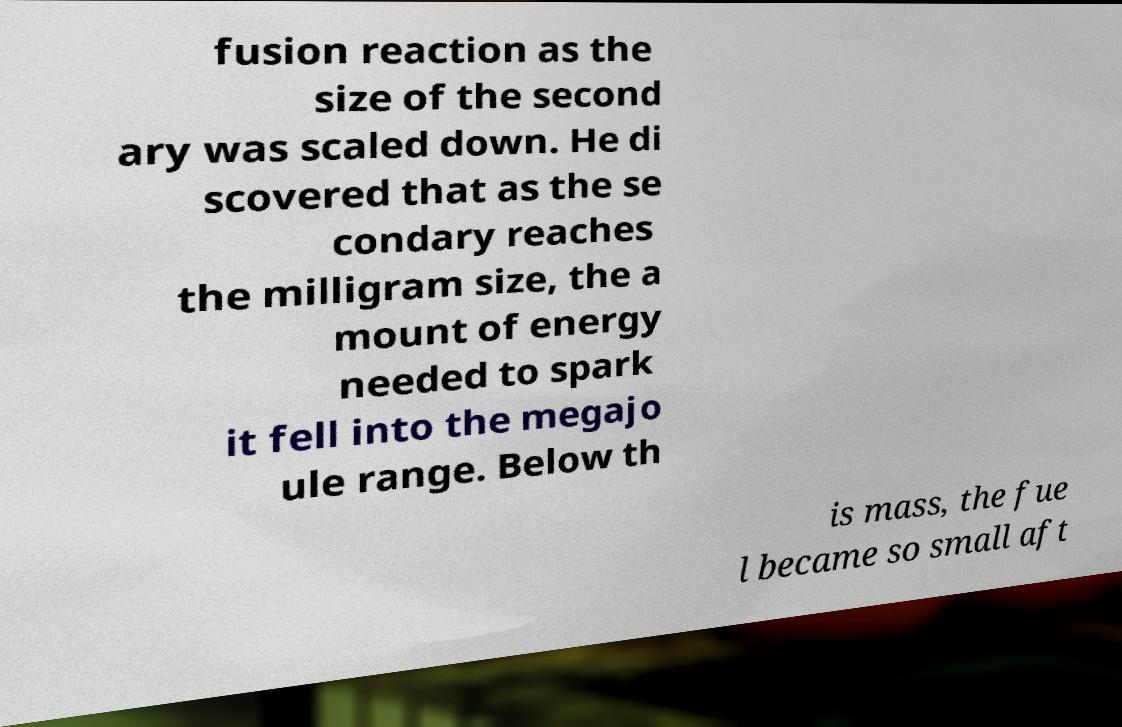Can you accurately transcribe the text from the provided image for me? fusion reaction as the size of the second ary was scaled down. He di scovered that as the se condary reaches the milligram size, the a mount of energy needed to spark it fell into the megajo ule range. Below th is mass, the fue l became so small aft 